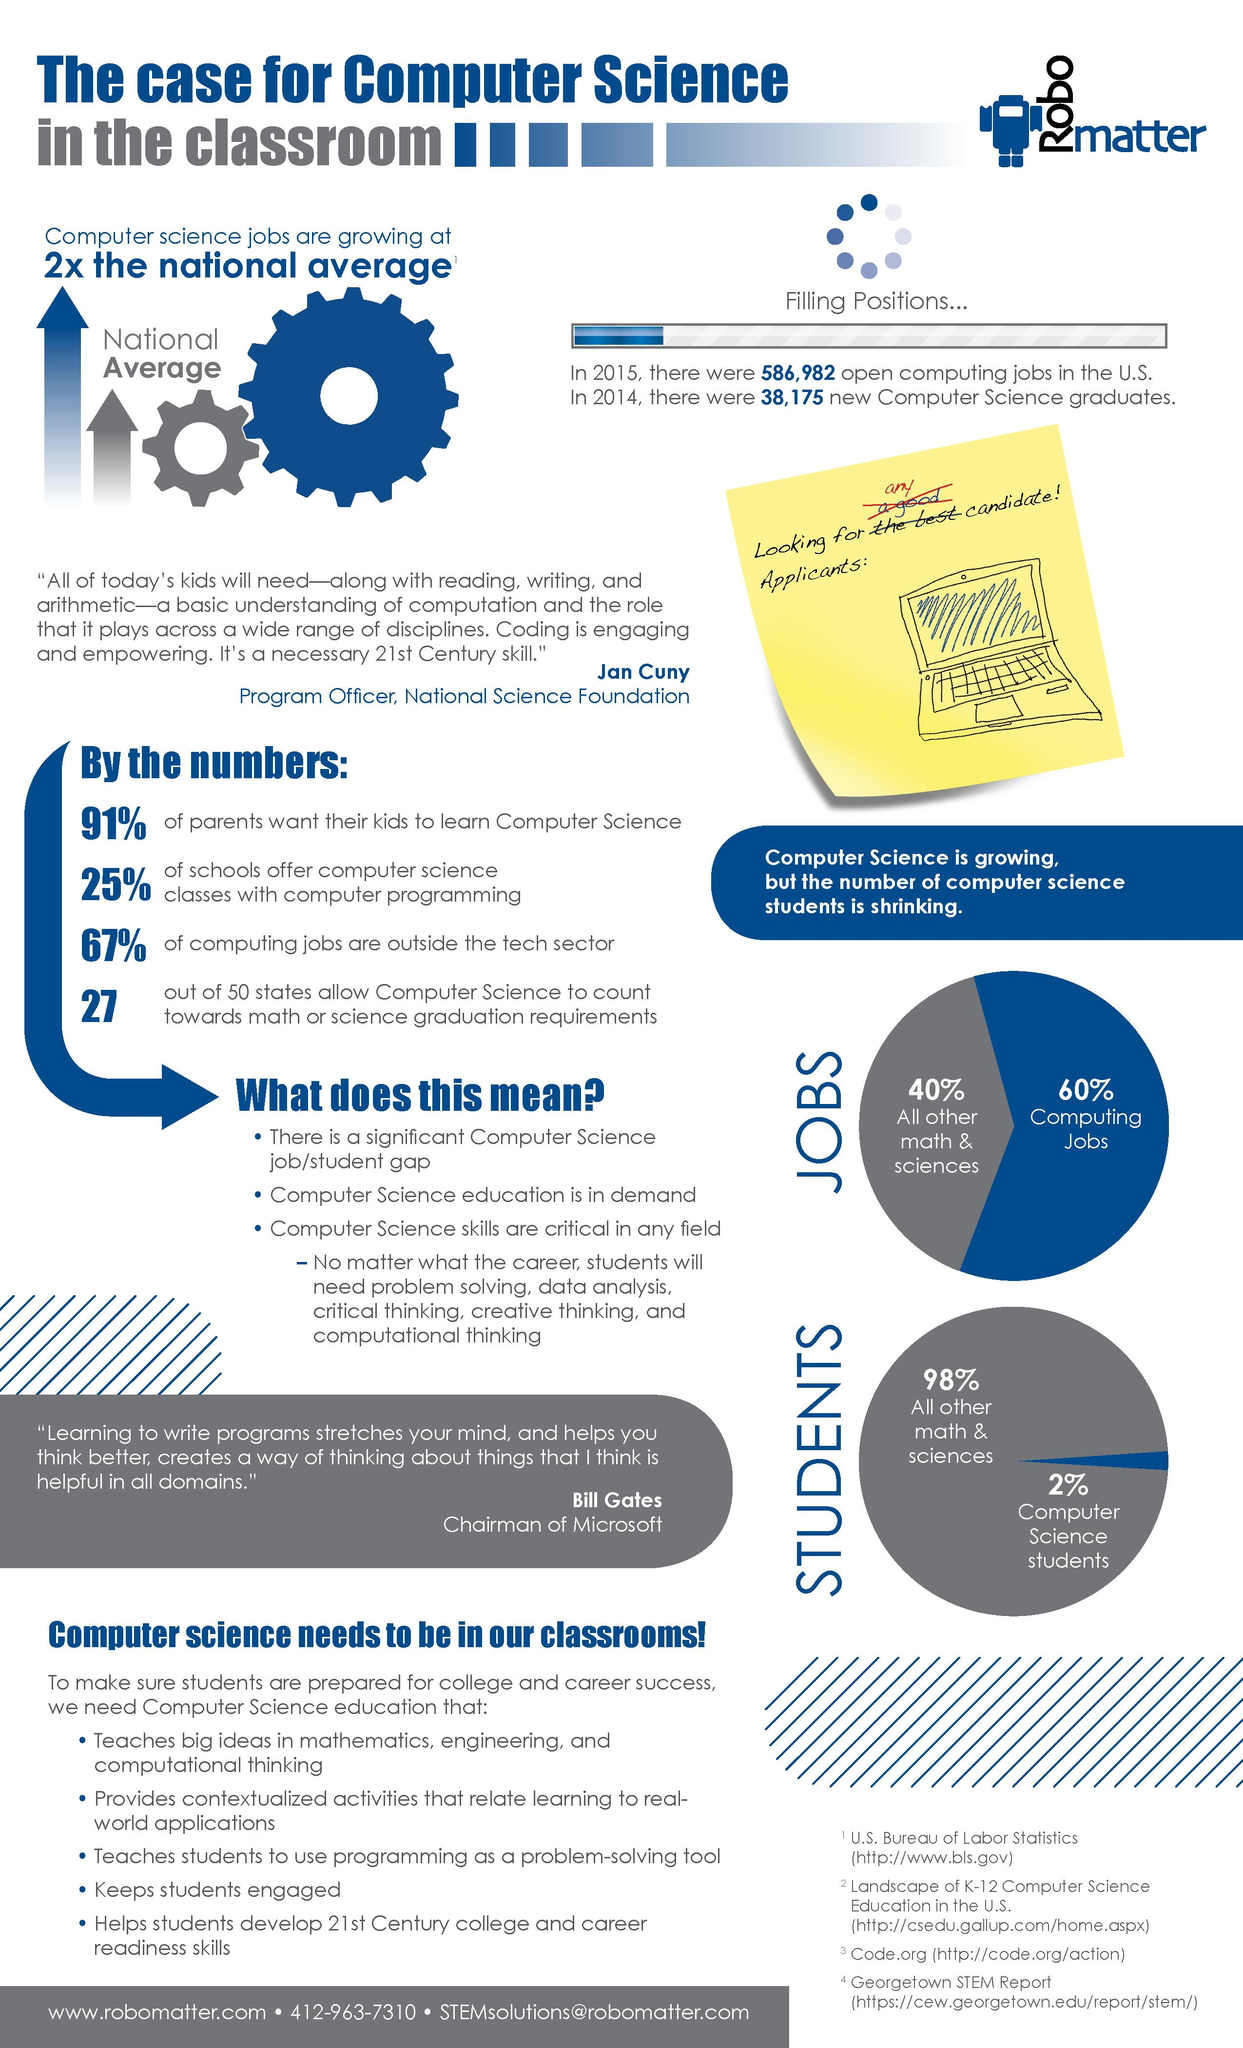Specify some key components in this picture. According to a recent study, 33% of computing jobs are not located within the tech sector. According to a recent survey, only 9% of parents do not want their children to learn computer science. 